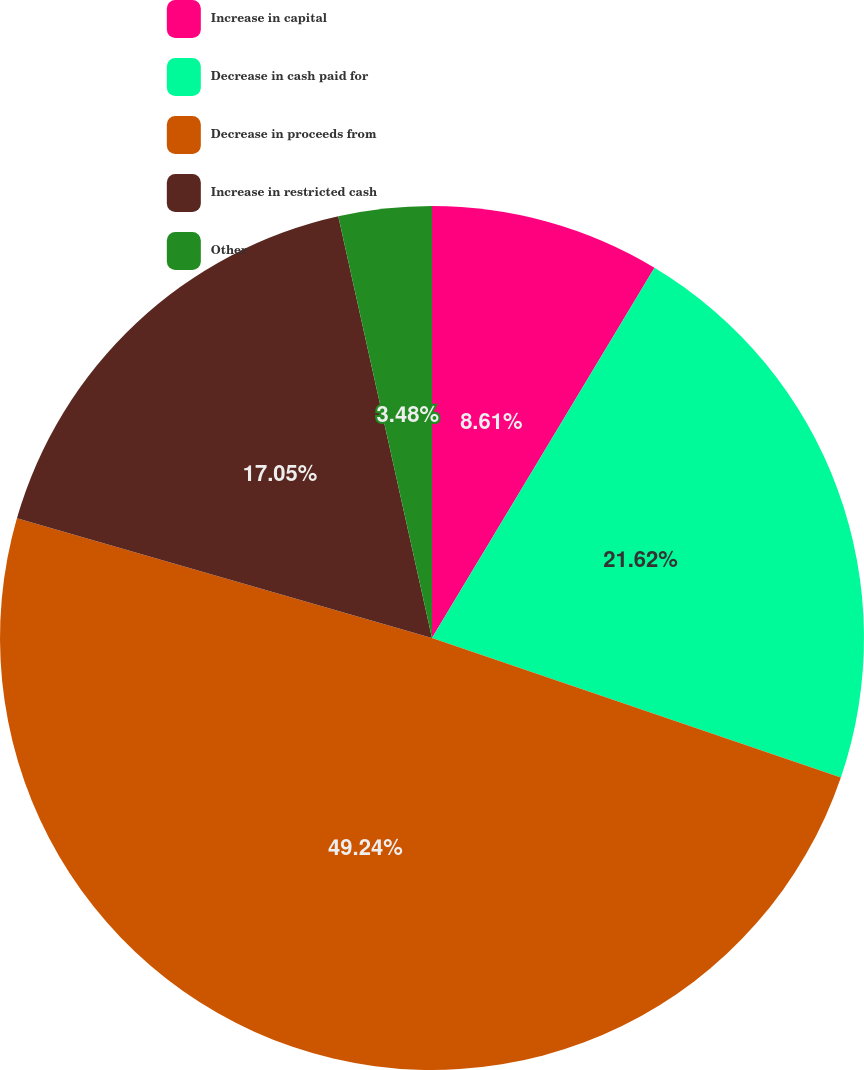<chart> <loc_0><loc_0><loc_500><loc_500><pie_chart><fcel>Increase in capital<fcel>Decrease in cash paid for<fcel>Decrease in proceeds from<fcel>Increase in restricted cash<fcel>Other<nl><fcel>8.61%<fcel>21.62%<fcel>49.23%<fcel>17.05%<fcel>3.48%<nl></chart> 